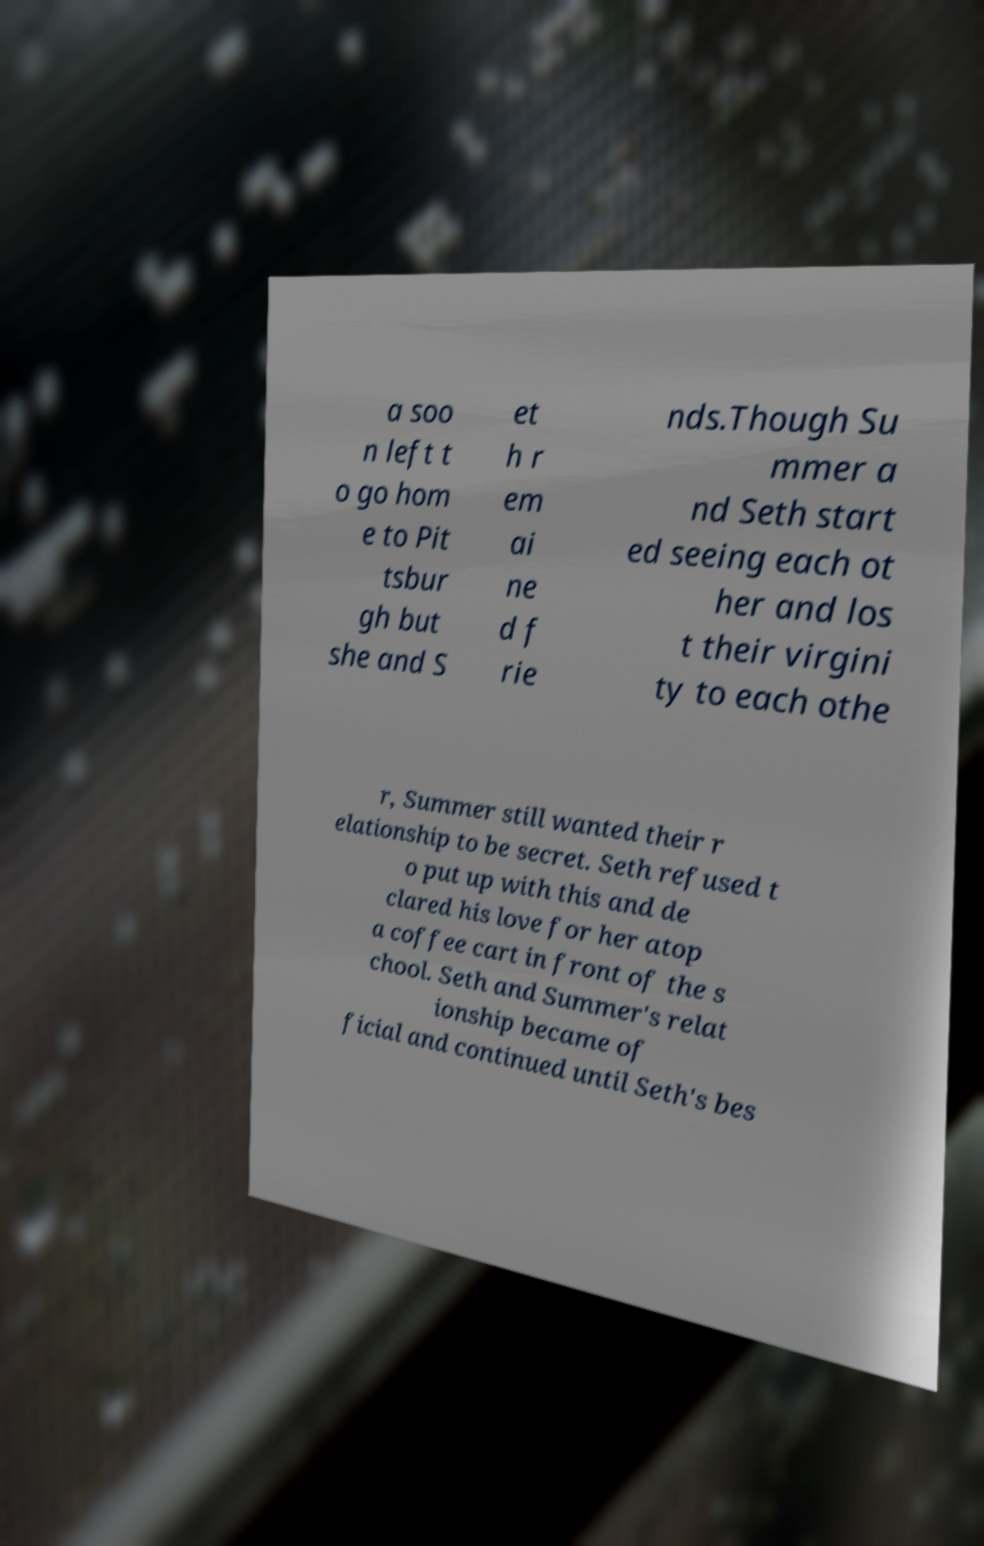Can you accurately transcribe the text from the provided image for me? a soo n left t o go hom e to Pit tsbur gh but she and S et h r em ai ne d f rie nds.Though Su mmer a nd Seth start ed seeing each ot her and los t their virgini ty to each othe r, Summer still wanted their r elationship to be secret. Seth refused t o put up with this and de clared his love for her atop a coffee cart in front of the s chool. Seth and Summer's relat ionship became of ficial and continued until Seth's bes 